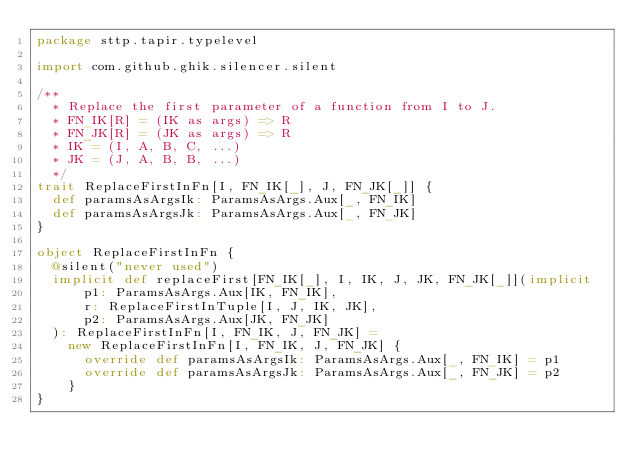<code> <loc_0><loc_0><loc_500><loc_500><_Scala_>package sttp.tapir.typelevel

import com.github.ghik.silencer.silent

/**
  * Replace the first parameter of a function from I to J.
  * FN_IK[R] = (IK as args) => R
  * FN_JK[R] = (JK as args) => R
  * IK = (I, A, B, C, ...)
  * JK = (J, A, B, B, ...)
  */
trait ReplaceFirstInFn[I, FN_IK[_], J, FN_JK[_]] {
  def paramsAsArgsIk: ParamsAsArgs.Aux[_, FN_IK]
  def paramsAsArgsJk: ParamsAsArgs.Aux[_, FN_JK]
}

object ReplaceFirstInFn {
  @silent("never used")
  implicit def replaceFirst[FN_IK[_], I, IK, J, JK, FN_JK[_]](implicit
      p1: ParamsAsArgs.Aux[IK, FN_IK],
      r: ReplaceFirstInTuple[I, J, IK, JK],
      p2: ParamsAsArgs.Aux[JK, FN_JK]
  ): ReplaceFirstInFn[I, FN_IK, J, FN_JK] =
    new ReplaceFirstInFn[I, FN_IK, J, FN_JK] {
      override def paramsAsArgsIk: ParamsAsArgs.Aux[_, FN_IK] = p1
      override def paramsAsArgsJk: ParamsAsArgs.Aux[_, FN_JK] = p2
    }
}
</code> 